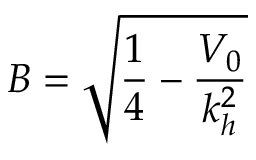Convert formula to latex. <formula><loc_0><loc_0><loc_500><loc_500>B = \sqrt { \frac { 1 } { 4 } - \frac { V _ { 0 } } { k _ { h } ^ { 2 } } }</formula> 